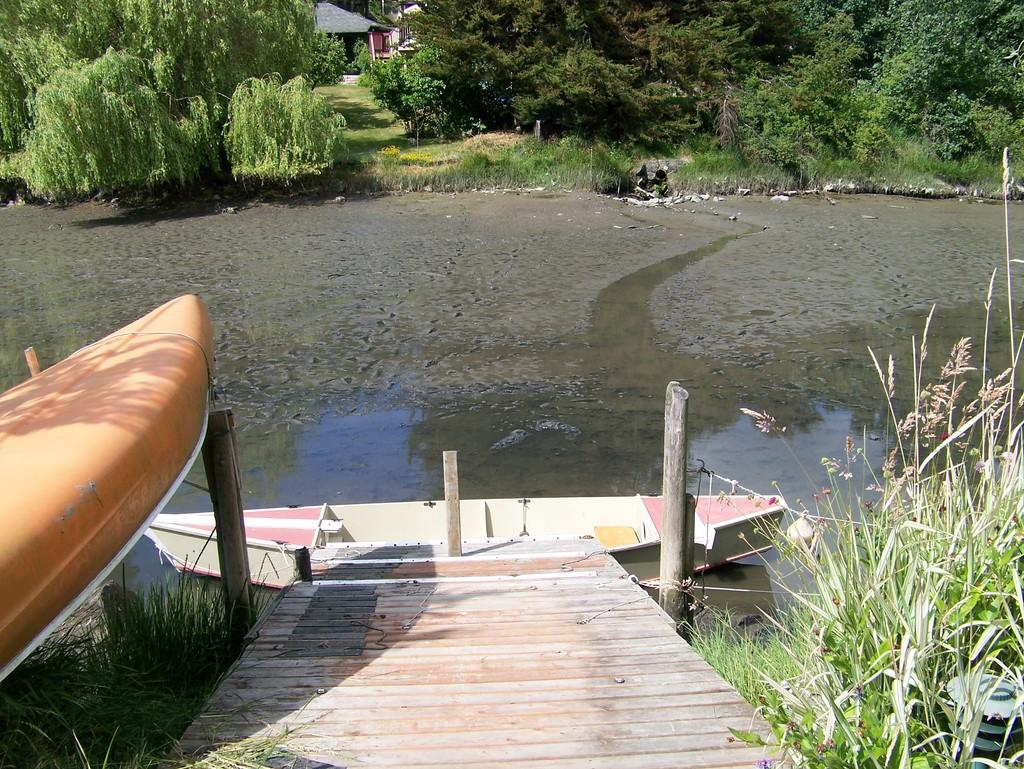What type of vegetation can be seen in the image? There is grass in the image. What kind of surface is visible in the image? There is a path in the image. What structures are present in the image? There are poles in the image. What objects are floating in the water? There are boats in the image. What can be seen in the water? Water is visible in the image. What type of natural scenery is visible in the background? There are trees and plants in the background of the image. What type of building is visible in the background? There is a house in the background of the image. How many maids are visible in the image? There are no maids present in the image. What type of wing is attached to the boats in the image? There are no wings present in the image, and the boats do not have wings. How many clocks can be seen in the image? There are no clocks visible in the image. 